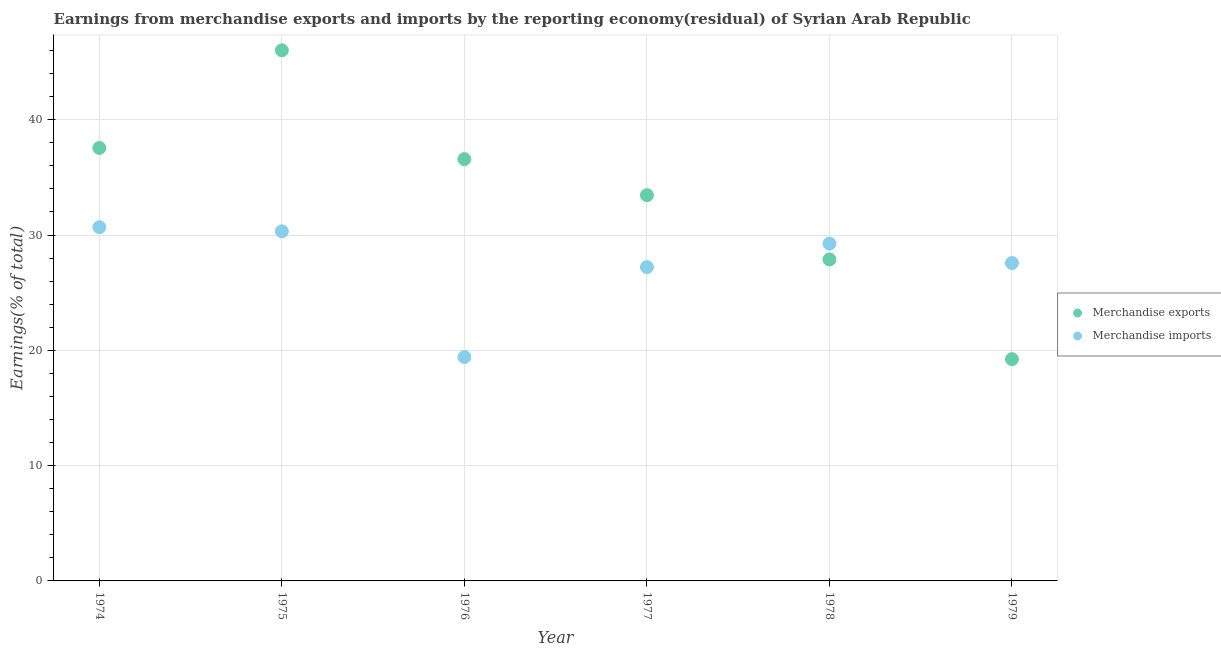How many different coloured dotlines are there?
Your response must be concise. 2. What is the earnings from merchandise imports in 1975?
Provide a short and direct response. 30.32. Across all years, what is the maximum earnings from merchandise imports?
Your response must be concise. 30.68. Across all years, what is the minimum earnings from merchandise exports?
Your response must be concise. 19.24. In which year was the earnings from merchandise imports maximum?
Provide a succinct answer. 1974. In which year was the earnings from merchandise exports minimum?
Give a very brief answer. 1979. What is the total earnings from merchandise exports in the graph?
Offer a very short reply. 200.73. What is the difference between the earnings from merchandise exports in 1975 and that in 1977?
Your answer should be very brief. 12.57. What is the difference between the earnings from merchandise exports in 1975 and the earnings from merchandise imports in 1978?
Give a very brief answer. 16.77. What is the average earnings from merchandise exports per year?
Make the answer very short. 33.46. In the year 1976, what is the difference between the earnings from merchandise imports and earnings from merchandise exports?
Provide a succinct answer. -17.17. What is the ratio of the earnings from merchandise imports in 1976 to that in 1978?
Keep it short and to the point. 0.66. What is the difference between the highest and the second highest earnings from merchandise imports?
Provide a succinct answer. 0.36. What is the difference between the highest and the lowest earnings from merchandise imports?
Your answer should be very brief. 11.26. In how many years, is the earnings from merchandise imports greater than the average earnings from merchandise imports taken over all years?
Give a very brief answer. 4. Is the sum of the earnings from merchandise imports in 1975 and 1979 greater than the maximum earnings from merchandise exports across all years?
Your answer should be very brief. Yes. Does the earnings from merchandise imports monotonically increase over the years?
Provide a succinct answer. No. Is the earnings from merchandise imports strictly greater than the earnings from merchandise exports over the years?
Your response must be concise. No. Is the earnings from merchandise imports strictly less than the earnings from merchandise exports over the years?
Your response must be concise. No. How many dotlines are there?
Give a very brief answer. 2. What is the title of the graph?
Your response must be concise. Earnings from merchandise exports and imports by the reporting economy(residual) of Syrian Arab Republic. What is the label or title of the X-axis?
Your response must be concise. Year. What is the label or title of the Y-axis?
Your response must be concise. Earnings(% of total). What is the Earnings(% of total) of Merchandise exports in 1974?
Your answer should be very brief. 37.55. What is the Earnings(% of total) of Merchandise imports in 1974?
Offer a terse response. 30.68. What is the Earnings(% of total) of Merchandise exports in 1975?
Provide a succinct answer. 46.02. What is the Earnings(% of total) in Merchandise imports in 1975?
Provide a succinct answer. 30.32. What is the Earnings(% of total) in Merchandise exports in 1976?
Ensure brevity in your answer.  36.59. What is the Earnings(% of total) in Merchandise imports in 1976?
Provide a succinct answer. 19.42. What is the Earnings(% of total) in Merchandise exports in 1977?
Your response must be concise. 33.45. What is the Earnings(% of total) in Merchandise imports in 1977?
Keep it short and to the point. 27.22. What is the Earnings(% of total) in Merchandise exports in 1978?
Offer a very short reply. 27.88. What is the Earnings(% of total) of Merchandise imports in 1978?
Offer a very short reply. 29.25. What is the Earnings(% of total) in Merchandise exports in 1979?
Your answer should be compact. 19.24. What is the Earnings(% of total) in Merchandise imports in 1979?
Your answer should be compact. 27.57. Across all years, what is the maximum Earnings(% of total) of Merchandise exports?
Provide a short and direct response. 46.02. Across all years, what is the maximum Earnings(% of total) in Merchandise imports?
Give a very brief answer. 30.68. Across all years, what is the minimum Earnings(% of total) of Merchandise exports?
Provide a short and direct response. 19.24. Across all years, what is the minimum Earnings(% of total) in Merchandise imports?
Keep it short and to the point. 19.42. What is the total Earnings(% of total) of Merchandise exports in the graph?
Keep it short and to the point. 200.73. What is the total Earnings(% of total) of Merchandise imports in the graph?
Ensure brevity in your answer.  164.46. What is the difference between the Earnings(% of total) in Merchandise exports in 1974 and that in 1975?
Your answer should be very brief. -8.47. What is the difference between the Earnings(% of total) in Merchandise imports in 1974 and that in 1975?
Give a very brief answer. 0.36. What is the difference between the Earnings(% of total) in Merchandise exports in 1974 and that in 1976?
Your answer should be compact. 0.97. What is the difference between the Earnings(% of total) of Merchandise imports in 1974 and that in 1976?
Make the answer very short. 11.26. What is the difference between the Earnings(% of total) of Merchandise exports in 1974 and that in 1977?
Offer a very short reply. 4.1. What is the difference between the Earnings(% of total) of Merchandise imports in 1974 and that in 1977?
Your answer should be very brief. 3.46. What is the difference between the Earnings(% of total) in Merchandise exports in 1974 and that in 1978?
Make the answer very short. 9.67. What is the difference between the Earnings(% of total) in Merchandise imports in 1974 and that in 1978?
Keep it short and to the point. 1.43. What is the difference between the Earnings(% of total) in Merchandise exports in 1974 and that in 1979?
Ensure brevity in your answer.  18.31. What is the difference between the Earnings(% of total) in Merchandise imports in 1974 and that in 1979?
Your answer should be compact. 3.11. What is the difference between the Earnings(% of total) of Merchandise exports in 1975 and that in 1976?
Offer a terse response. 9.44. What is the difference between the Earnings(% of total) in Merchandise imports in 1975 and that in 1976?
Offer a terse response. 10.91. What is the difference between the Earnings(% of total) in Merchandise exports in 1975 and that in 1977?
Provide a short and direct response. 12.57. What is the difference between the Earnings(% of total) of Merchandise imports in 1975 and that in 1977?
Ensure brevity in your answer.  3.11. What is the difference between the Earnings(% of total) in Merchandise exports in 1975 and that in 1978?
Keep it short and to the point. 18.14. What is the difference between the Earnings(% of total) of Merchandise imports in 1975 and that in 1978?
Make the answer very short. 1.07. What is the difference between the Earnings(% of total) of Merchandise exports in 1975 and that in 1979?
Your response must be concise. 26.78. What is the difference between the Earnings(% of total) of Merchandise imports in 1975 and that in 1979?
Provide a succinct answer. 2.75. What is the difference between the Earnings(% of total) in Merchandise exports in 1976 and that in 1977?
Your answer should be very brief. 3.13. What is the difference between the Earnings(% of total) of Merchandise imports in 1976 and that in 1977?
Keep it short and to the point. -7.8. What is the difference between the Earnings(% of total) of Merchandise exports in 1976 and that in 1978?
Provide a short and direct response. 8.7. What is the difference between the Earnings(% of total) of Merchandise imports in 1976 and that in 1978?
Your answer should be very brief. -9.84. What is the difference between the Earnings(% of total) of Merchandise exports in 1976 and that in 1979?
Make the answer very short. 17.35. What is the difference between the Earnings(% of total) of Merchandise imports in 1976 and that in 1979?
Give a very brief answer. -8.16. What is the difference between the Earnings(% of total) of Merchandise exports in 1977 and that in 1978?
Provide a succinct answer. 5.57. What is the difference between the Earnings(% of total) of Merchandise imports in 1977 and that in 1978?
Make the answer very short. -2.03. What is the difference between the Earnings(% of total) of Merchandise exports in 1977 and that in 1979?
Provide a short and direct response. 14.22. What is the difference between the Earnings(% of total) in Merchandise imports in 1977 and that in 1979?
Give a very brief answer. -0.35. What is the difference between the Earnings(% of total) of Merchandise exports in 1978 and that in 1979?
Provide a short and direct response. 8.65. What is the difference between the Earnings(% of total) in Merchandise imports in 1978 and that in 1979?
Offer a terse response. 1.68. What is the difference between the Earnings(% of total) in Merchandise exports in 1974 and the Earnings(% of total) in Merchandise imports in 1975?
Make the answer very short. 7.23. What is the difference between the Earnings(% of total) in Merchandise exports in 1974 and the Earnings(% of total) in Merchandise imports in 1976?
Provide a short and direct response. 18.14. What is the difference between the Earnings(% of total) in Merchandise exports in 1974 and the Earnings(% of total) in Merchandise imports in 1977?
Your answer should be very brief. 10.33. What is the difference between the Earnings(% of total) of Merchandise exports in 1974 and the Earnings(% of total) of Merchandise imports in 1978?
Provide a short and direct response. 8.3. What is the difference between the Earnings(% of total) of Merchandise exports in 1974 and the Earnings(% of total) of Merchandise imports in 1979?
Your answer should be compact. 9.98. What is the difference between the Earnings(% of total) of Merchandise exports in 1975 and the Earnings(% of total) of Merchandise imports in 1976?
Your response must be concise. 26.6. What is the difference between the Earnings(% of total) of Merchandise exports in 1975 and the Earnings(% of total) of Merchandise imports in 1977?
Give a very brief answer. 18.8. What is the difference between the Earnings(% of total) in Merchandise exports in 1975 and the Earnings(% of total) in Merchandise imports in 1978?
Your answer should be very brief. 16.77. What is the difference between the Earnings(% of total) of Merchandise exports in 1975 and the Earnings(% of total) of Merchandise imports in 1979?
Offer a terse response. 18.45. What is the difference between the Earnings(% of total) of Merchandise exports in 1976 and the Earnings(% of total) of Merchandise imports in 1977?
Your answer should be compact. 9.37. What is the difference between the Earnings(% of total) in Merchandise exports in 1976 and the Earnings(% of total) in Merchandise imports in 1978?
Ensure brevity in your answer.  7.33. What is the difference between the Earnings(% of total) in Merchandise exports in 1976 and the Earnings(% of total) in Merchandise imports in 1979?
Provide a succinct answer. 9.01. What is the difference between the Earnings(% of total) in Merchandise exports in 1977 and the Earnings(% of total) in Merchandise imports in 1978?
Give a very brief answer. 4.2. What is the difference between the Earnings(% of total) in Merchandise exports in 1977 and the Earnings(% of total) in Merchandise imports in 1979?
Ensure brevity in your answer.  5.88. What is the difference between the Earnings(% of total) of Merchandise exports in 1978 and the Earnings(% of total) of Merchandise imports in 1979?
Your answer should be compact. 0.31. What is the average Earnings(% of total) in Merchandise exports per year?
Your response must be concise. 33.46. What is the average Earnings(% of total) of Merchandise imports per year?
Offer a terse response. 27.41. In the year 1974, what is the difference between the Earnings(% of total) of Merchandise exports and Earnings(% of total) of Merchandise imports?
Your answer should be compact. 6.87. In the year 1975, what is the difference between the Earnings(% of total) of Merchandise exports and Earnings(% of total) of Merchandise imports?
Make the answer very short. 15.7. In the year 1976, what is the difference between the Earnings(% of total) in Merchandise exports and Earnings(% of total) in Merchandise imports?
Your response must be concise. 17.17. In the year 1977, what is the difference between the Earnings(% of total) in Merchandise exports and Earnings(% of total) in Merchandise imports?
Offer a very short reply. 6.24. In the year 1978, what is the difference between the Earnings(% of total) in Merchandise exports and Earnings(% of total) in Merchandise imports?
Provide a short and direct response. -1.37. In the year 1979, what is the difference between the Earnings(% of total) of Merchandise exports and Earnings(% of total) of Merchandise imports?
Offer a terse response. -8.34. What is the ratio of the Earnings(% of total) of Merchandise exports in 1974 to that in 1975?
Your answer should be very brief. 0.82. What is the ratio of the Earnings(% of total) of Merchandise imports in 1974 to that in 1975?
Offer a terse response. 1.01. What is the ratio of the Earnings(% of total) of Merchandise exports in 1974 to that in 1976?
Your response must be concise. 1.03. What is the ratio of the Earnings(% of total) of Merchandise imports in 1974 to that in 1976?
Your response must be concise. 1.58. What is the ratio of the Earnings(% of total) of Merchandise exports in 1974 to that in 1977?
Offer a terse response. 1.12. What is the ratio of the Earnings(% of total) in Merchandise imports in 1974 to that in 1977?
Provide a succinct answer. 1.13. What is the ratio of the Earnings(% of total) of Merchandise exports in 1974 to that in 1978?
Make the answer very short. 1.35. What is the ratio of the Earnings(% of total) of Merchandise imports in 1974 to that in 1978?
Offer a terse response. 1.05. What is the ratio of the Earnings(% of total) in Merchandise exports in 1974 to that in 1979?
Keep it short and to the point. 1.95. What is the ratio of the Earnings(% of total) of Merchandise imports in 1974 to that in 1979?
Your response must be concise. 1.11. What is the ratio of the Earnings(% of total) of Merchandise exports in 1975 to that in 1976?
Your answer should be very brief. 1.26. What is the ratio of the Earnings(% of total) of Merchandise imports in 1975 to that in 1976?
Make the answer very short. 1.56. What is the ratio of the Earnings(% of total) of Merchandise exports in 1975 to that in 1977?
Offer a very short reply. 1.38. What is the ratio of the Earnings(% of total) of Merchandise imports in 1975 to that in 1977?
Keep it short and to the point. 1.11. What is the ratio of the Earnings(% of total) of Merchandise exports in 1975 to that in 1978?
Keep it short and to the point. 1.65. What is the ratio of the Earnings(% of total) of Merchandise imports in 1975 to that in 1978?
Provide a succinct answer. 1.04. What is the ratio of the Earnings(% of total) of Merchandise exports in 1975 to that in 1979?
Offer a terse response. 2.39. What is the ratio of the Earnings(% of total) in Merchandise imports in 1975 to that in 1979?
Provide a succinct answer. 1.1. What is the ratio of the Earnings(% of total) in Merchandise exports in 1976 to that in 1977?
Offer a very short reply. 1.09. What is the ratio of the Earnings(% of total) in Merchandise imports in 1976 to that in 1977?
Your answer should be very brief. 0.71. What is the ratio of the Earnings(% of total) of Merchandise exports in 1976 to that in 1978?
Keep it short and to the point. 1.31. What is the ratio of the Earnings(% of total) of Merchandise imports in 1976 to that in 1978?
Offer a very short reply. 0.66. What is the ratio of the Earnings(% of total) of Merchandise exports in 1976 to that in 1979?
Provide a short and direct response. 1.9. What is the ratio of the Earnings(% of total) in Merchandise imports in 1976 to that in 1979?
Offer a terse response. 0.7. What is the ratio of the Earnings(% of total) in Merchandise exports in 1977 to that in 1978?
Make the answer very short. 1.2. What is the ratio of the Earnings(% of total) of Merchandise imports in 1977 to that in 1978?
Offer a terse response. 0.93. What is the ratio of the Earnings(% of total) of Merchandise exports in 1977 to that in 1979?
Keep it short and to the point. 1.74. What is the ratio of the Earnings(% of total) in Merchandise imports in 1977 to that in 1979?
Keep it short and to the point. 0.99. What is the ratio of the Earnings(% of total) in Merchandise exports in 1978 to that in 1979?
Your answer should be very brief. 1.45. What is the ratio of the Earnings(% of total) in Merchandise imports in 1978 to that in 1979?
Ensure brevity in your answer.  1.06. What is the difference between the highest and the second highest Earnings(% of total) of Merchandise exports?
Ensure brevity in your answer.  8.47. What is the difference between the highest and the second highest Earnings(% of total) in Merchandise imports?
Make the answer very short. 0.36. What is the difference between the highest and the lowest Earnings(% of total) in Merchandise exports?
Provide a succinct answer. 26.78. What is the difference between the highest and the lowest Earnings(% of total) of Merchandise imports?
Provide a short and direct response. 11.26. 